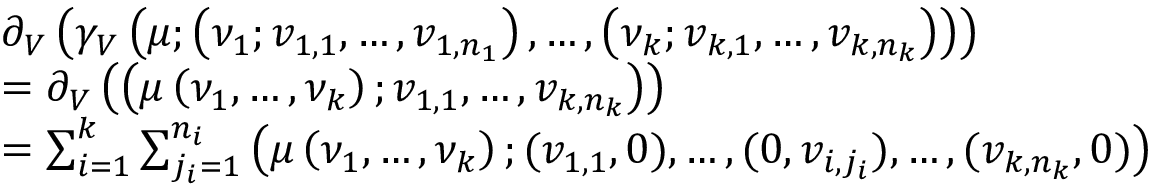<formula> <loc_0><loc_0><loc_500><loc_500>\begin{array} { r l } & { \partial _ { V } \left ( \gamma _ { V } \left ( \mu ; \left ( \nu _ { 1 } ; v _ { 1 , 1 } , \hdots , v _ { 1 , n _ { 1 } } \right ) , \hdots , \left ( \nu _ { k } ; v _ { k , 1 } , \hdots , v _ { k , n _ { k } } \right ) \right ) \right ) } \\ & { = \partial _ { V } \left ( \left ( \mu \left ( \nu _ { 1 } , \hdots , \nu _ { k } \right ) ; v _ { 1 , 1 } , \hdots , v _ { k , n _ { k } } \right ) \right ) } \\ & { = \sum _ { i = 1 } ^ { k } \sum _ { j _ { i } = 1 } ^ { n _ { i } } \left ( \mu \left ( \nu _ { 1 } , \hdots , \nu _ { k } \right ) ; ( v _ { 1 , 1 } , 0 ) , \hdots , ( 0 , v _ { i , j _ { i } } ) , \hdots , ( v _ { k , n _ { k } } , 0 ) \right ) } \end{array}</formula> 